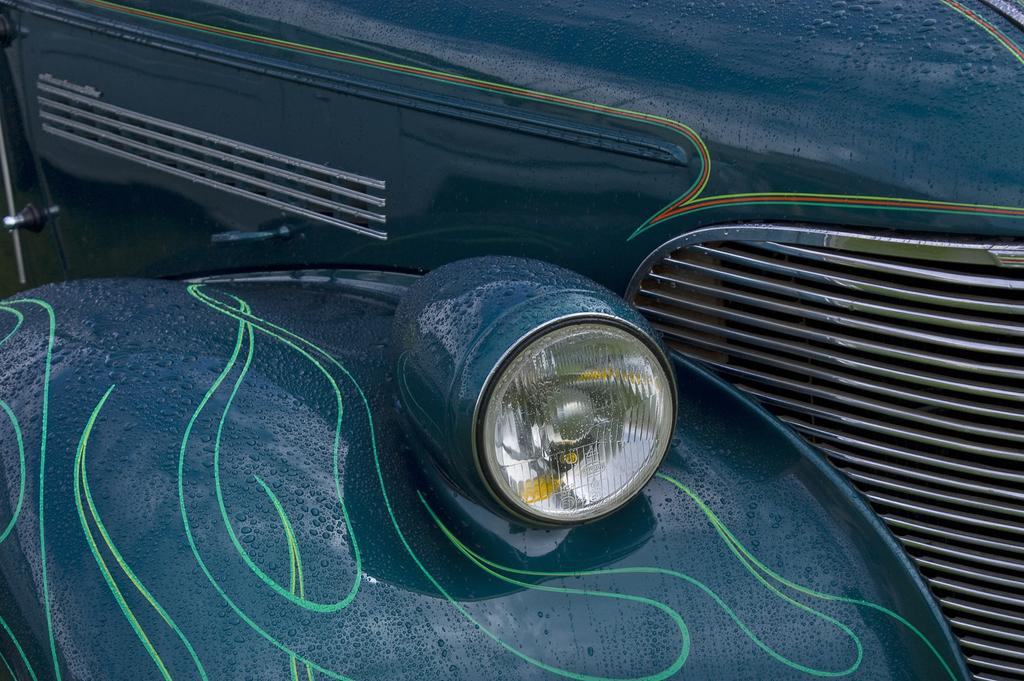What is the main subject of the image? The main subject of the image is the headlight of a car. Can you describe the headlight in more detail? Unfortunately, the provided facts do not offer any additional details about the headlight. Is there anything else visible in the image besides the headlight? The facts do not mention any other objects or elements in the image. What angle does the person's kick make with the ground in the image? There is no person or kick present in the image; it only features the headlight of a car. 